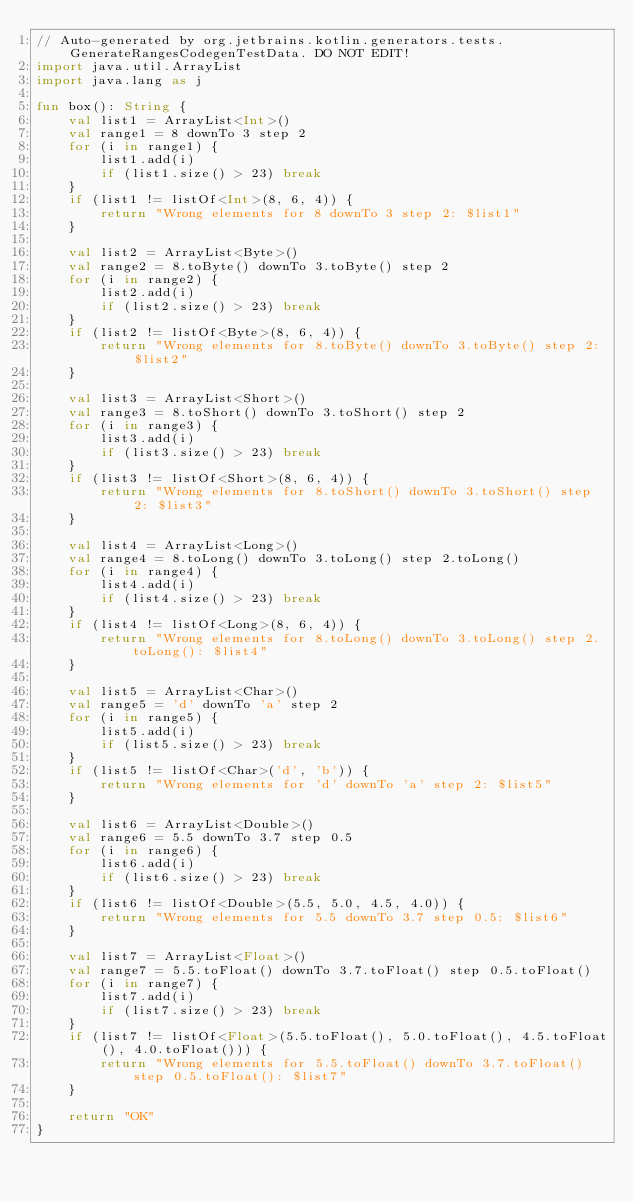Convert code to text. <code><loc_0><loc_0><loc_500><loc_500><_Kotlin_>// Auto-generated by org.jetbrains.kotlin.generators.tests.GenerateRangesCodegenTestData. DO NOT EDIT!
import java.util.ArrayList
import java.lang as j

fun box(): String {
    val list1 = ArrayList<Int>()
    val range1 = 8 downTo 3 step 2
    for (i in range1) {
        list1.add(i)
        if (list1.size() > 23) break
    }
    if (list1 != listOf<Int>(8, 6, 4)) {
        return "Wrong elements for 8 downTo 3 step 2: $list1"
    }

    val list2 = ArrayList<Byte>()
    val range2 = 8.toByte() downTo 3.toByte() step 2
    for (i in range2) {
        list2.add(i)
        if (list2.size() > 23) break
    }
    if (list2 != listOf<Byte>(8, 6, 4)) {
        return "Wrong elements for 8.toByte() downTo 3.toByte() step 2: $list2"
    }

    val list3 = ArrayList<Short>()
    val range3 = 8.toShort() downTo 3.toShort() step 2
    for (i in range3) {
        list3.add(i)
        if (list3.size() > 23) break
    }
    if (list3 != listOf<Short>(8, 6, 4)) {
        return "Wrong elements for 8.toShort() downTo 3.toShort() step 2: $list3"
    }

    val list4 = ArrayList<Long>()
    val range4 = 8.toLong() downTo 3.toLong() step 2.toLong()
    for (i in range4) {
        list4.add(i)
        if (list4.size() > 23) break
    }
    if (list4 != listOf<Long>(8, 6, 4)) {
        return "Wrong elements for 8.toLong() downTo 3.toLong() step 2.toLong(): $list4"
    }

    val list5 = ArrayList<Char>()
    val range5 = 'd' downTo 'a' step 2
    for (i in range5) {
        list5.add(i)
        if (list5.size() > 23) break
    }
    if (list5 != listOf<Char>('d', 'b')) {
        return "Wrong elements for 'd' downTo 'a' step 2: $list5"
    }

    val list6 = ArrayList<Double>()
    val range6 = 5.5 downTo 3.7 step 0.5
    for (i in range6) {
        list6.add(i)
        if (list6.size() > 23) break
    }
    if (list6 != listOf<Double>(5.5, 5.0, 4.5, 4.0)) {
        return "Wrong elements for 5.5 downTo 3.7 step 0.5: $list6"
    }

    val list7 = ArrayList<Float>()
    val range7 = 5.5.toFloat() downTo 3.7.toFloat() step 0.5.toFloat()
    for (i in range7) {
        list7.add(i)
        if (list7.size() > 23) break
    }
    if (list7 != listOf<Float>(5.5.toFloat(), 5.0.toFloat(), 4.5.toFloat(), 4.0.toFloat())) {
        return "Wrong elements for 5.5.toFloat() downTo 3.7.toFloat() step 0.5.toFloat(): $list7"
    }

    return "OK"
}
</code> 